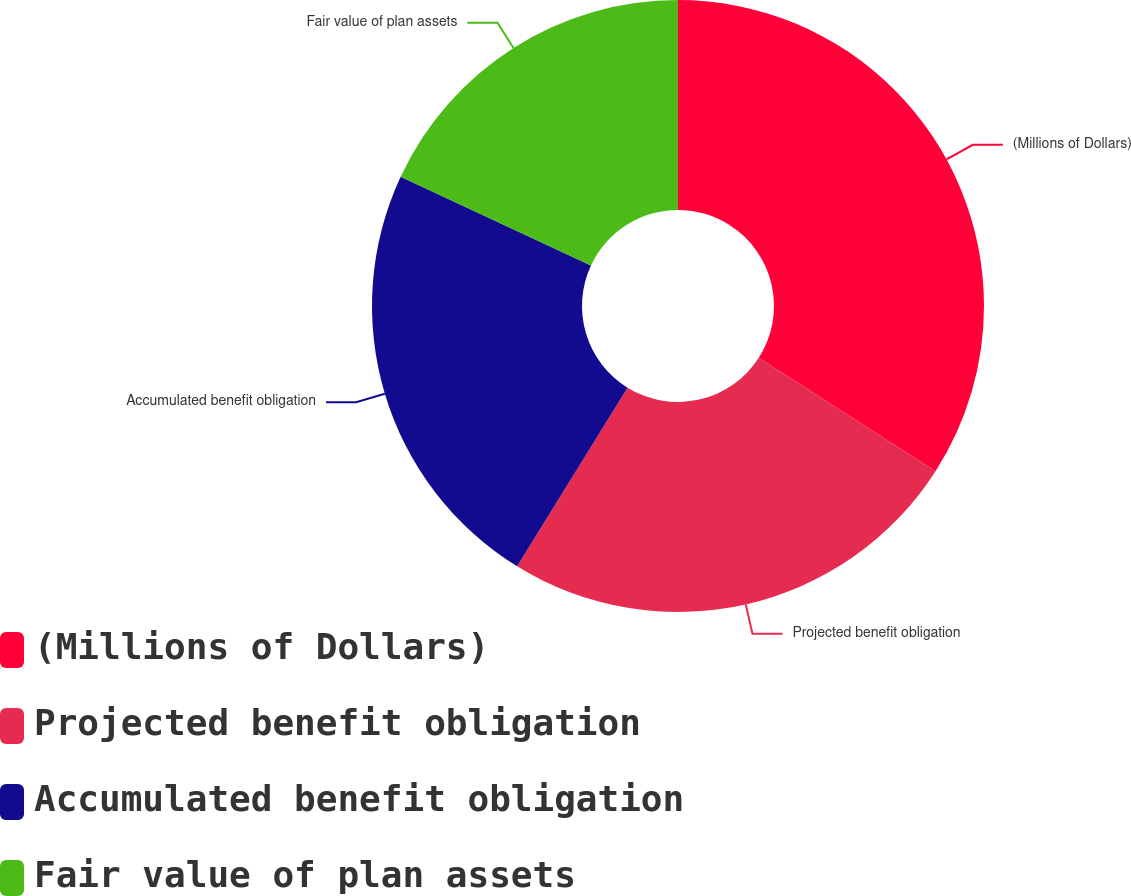Convert chart. <chart><loc_0><loc_0><loc_500><loc_500><pie_chart><fcel>(Millions of Dollars)<fcel>Projected benefit obligation<fcel>Accumulated benefit obligation<fcel>Fair value of plan assets<nl><fcel>34.08%<fcel>24.73%<fcel>23.13%<fcel>18.06%<nl></chart> 